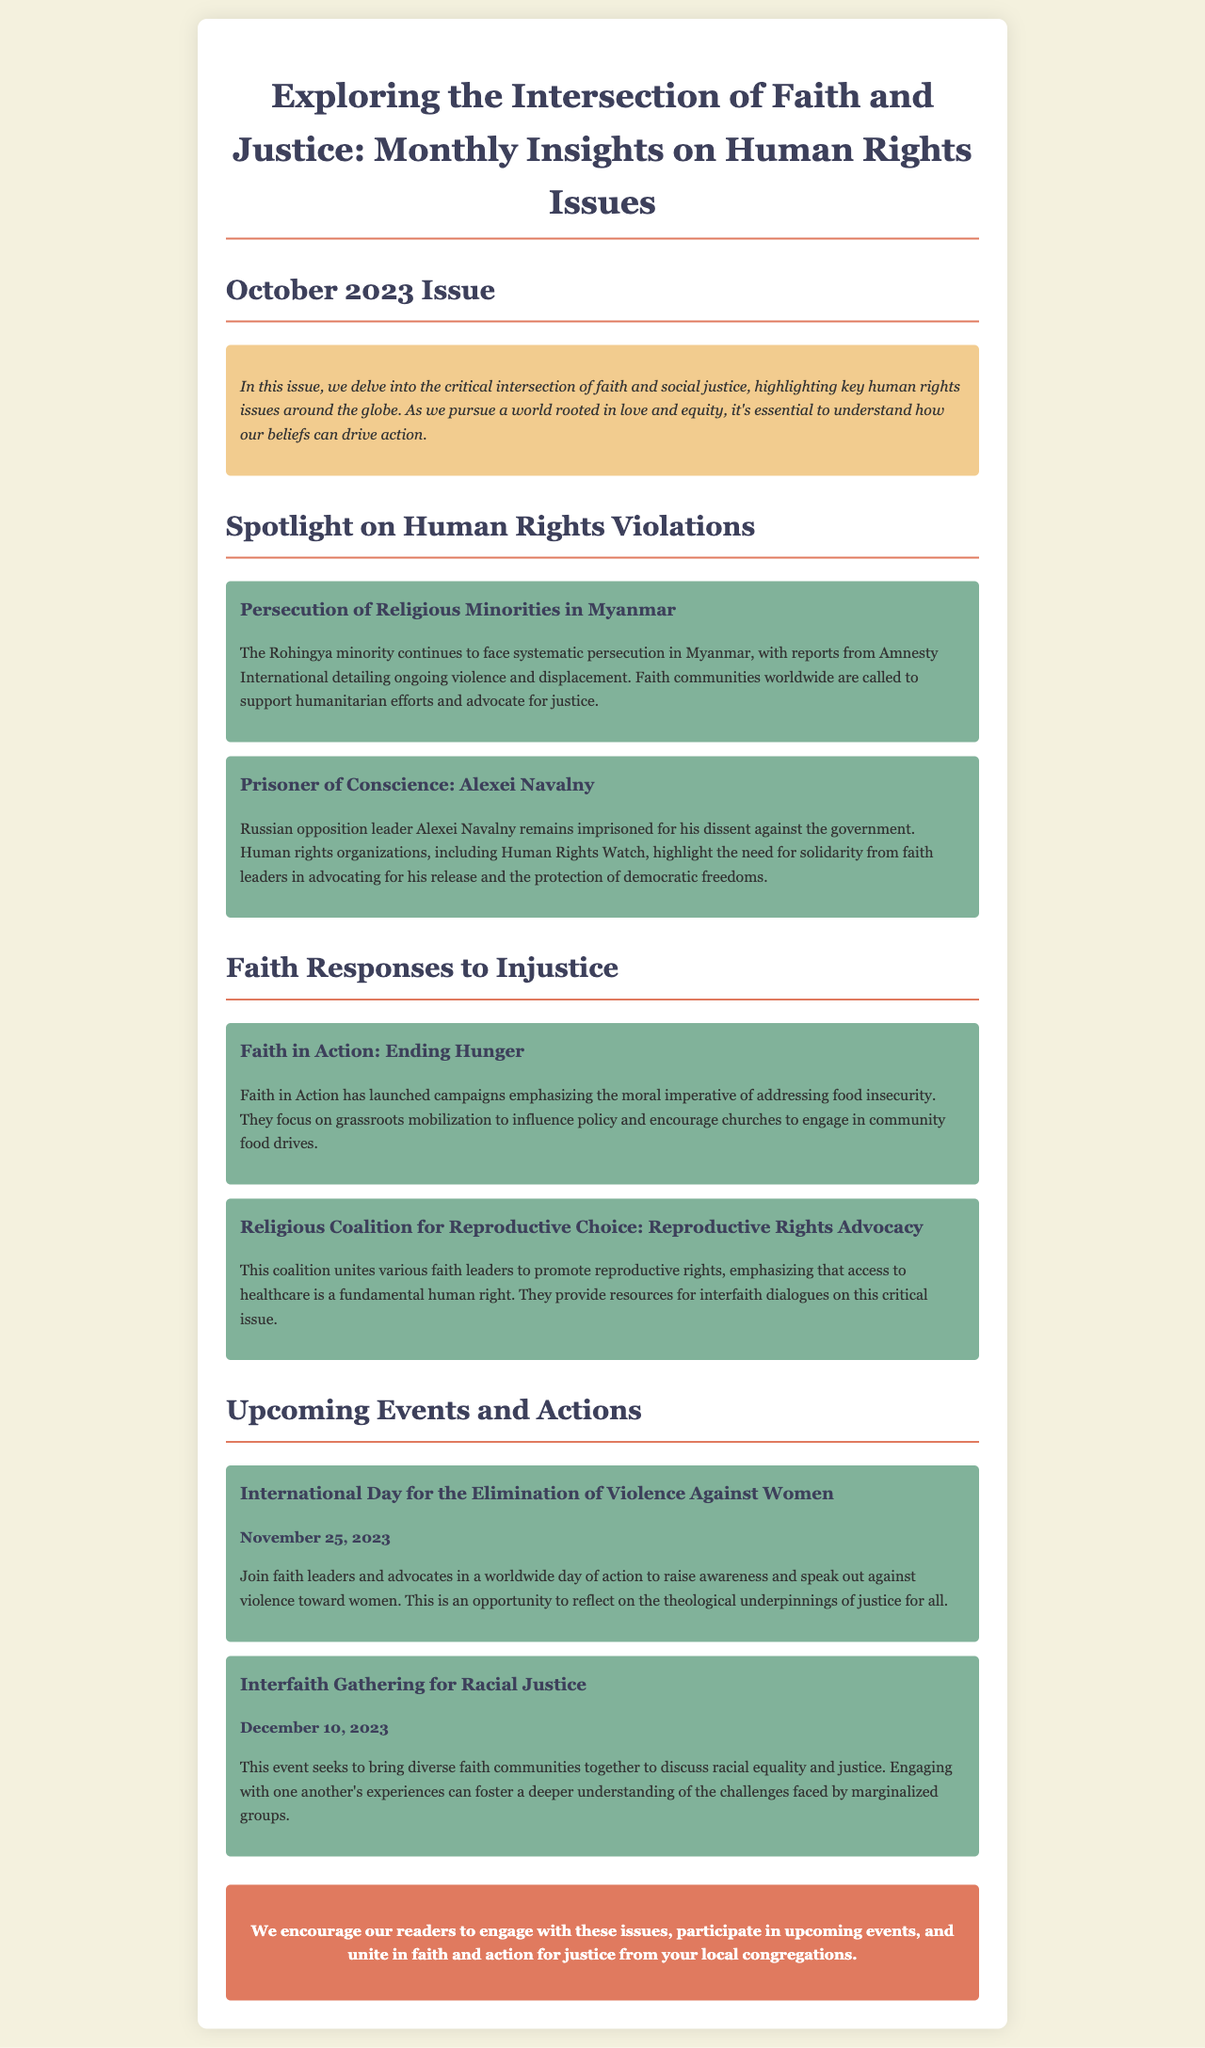What is the main theme of this newsletter? The newsletter discusses the intersection of faith and social justice, focusing on human rights issues.
Answer: Intersection of faith and justice Which country is highlighted for the persecution of religious minorities? The document mentions Myanmar in relation to the persecution of the Rohingya minority.
Answer: Myanmar What is the name of the Russian opposition leader mentioned? The newsletter refers to the imprisoned Russian opposition leader as Alexei Navalny.
Answer: Alexei Navalny When is the International Day for the Elimination of Violence Against Women? The date for this event is specified as November 25, 2023.
Answer: November 25, 2023 What organization emphasizes the moral imperative of addressing food insecurity? The document mentions Faith in Action regarding campaigns against hunger.
Answer: Faith in Action How many initiatives are discussed in the section about faith responses to injustice? There are two initiatives highlighted: one about hunger and another about reproductive rights.
Answer: Two What is the purpose of the Interfaith Gathering for Racial Justice? This gathering aims to discuss racial equality and justice among diverse faith communities.
Answer: Discuss racial equality and justice What kind of support is encouraged for the Rohingya minority? The newsletter urges faith communities to support humanitarian efforts and advocate for justice for the Rohingya.
Answer: Support humanitarian efforts and advocate for justice 